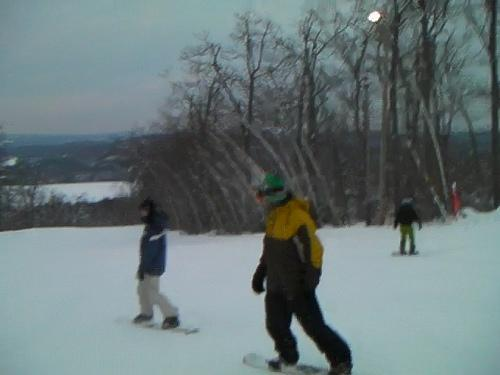What does the white light come from? Please explain your reasoning. lamp. There is a light in the sky that is illuminating the area. 